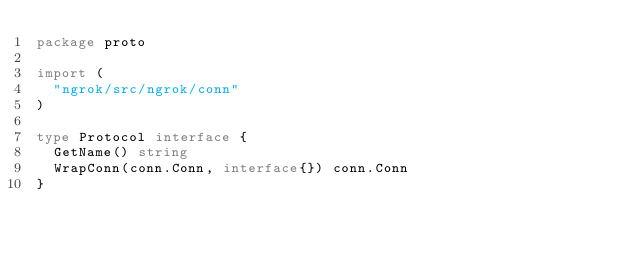Convert code to text. <code><loc_0><loc_0><loc_500><loc_500><_Go_>package proto

import (
	"ngrok/src/ngrok/conn"
)

type Protocol interface {
	GetName() string
	WrapConn(conn.Conn, interface{}) conn.Conn
}
</code> 